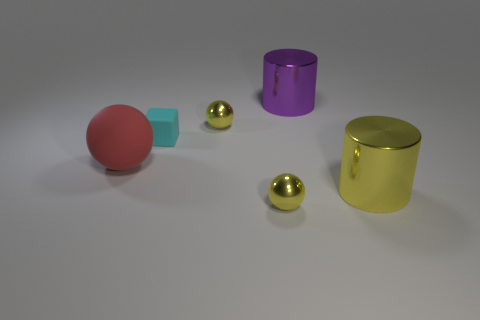How many other objects are there of the same size as the purple cylinder?
Your answer should be very brief. 2. How many big things are in front of the small cyan object and to the right of the red matte object?
Keep it short and to the point. 1. Do the big cylinder that is in front of the red rubber thing and the purple thing have the same material?
Your answer should be very brief. Yes. There is a tiny thing left of the small yellow ball that is behind the large metal cylinder on the right side of the purple thing; what is its shape?
Provide a short and direct response. Cube. Are there the same number of tiny shiny balls that are in front of the red matte ball and small yellow metal things that are in front of the yellow cylinder?
Offer a very short reply. Yes. What color is the cylinder that is the same size as the purple object?
Ensure brevity in your answer.  Yellow. How many large objects are either red matte spheres or yellow cylinders?
Keep it short and to the point. 2. What is the thing that is left of the big purple object and behind the tiny cyan matte thing made of?
Offer a very short reply. Metal. Is the shape of the big metal object that is left of the large yellow shiny cylinder the same as the small shiny object that is in front of the tiny cyan thing?
Your answer should be compact. No. How many things are tiny yellow metal balls that are in front of the cyan object or balls?
Keep it short and to the point. 3. 